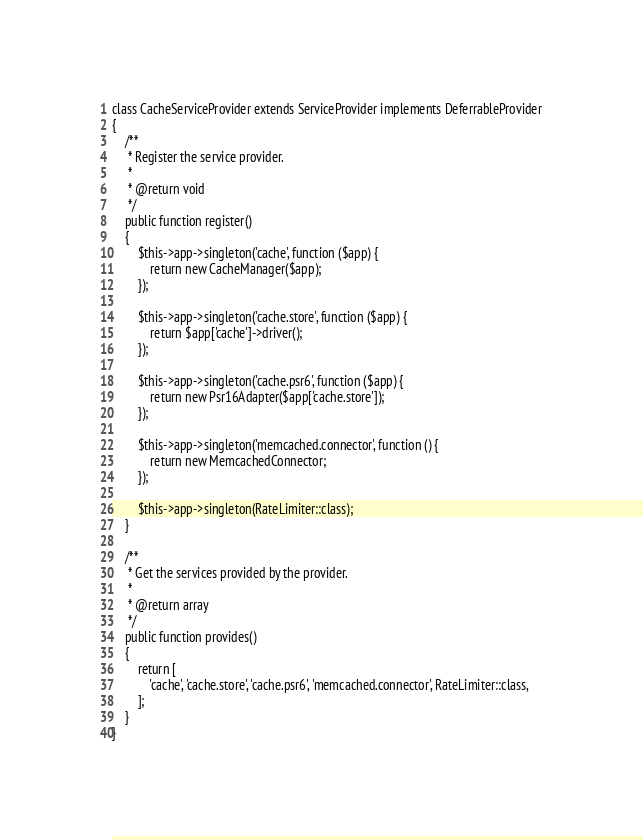Convert code to text. <code><loc_0><loc_0><loc_500><loc_500><_PHP_>
class CacheServiceProvider extends ServiceProvider implements DeferrableProvider
{
    /**
     * Register the service provider.
     *
     * @return void
     */
    public function register()
    {
        $this->app->singleton('cache', function ($app) {
            return new CacheManager($app);
        });

        $this->app->singleton('cache.store', function ($app) {
            return $app['cache']->driver();
        });

        $this->app->singleton('cache.psr6', function ($app) {
            return new Psr16Adapter($app['cache.store']);
        });

        $this->app->singleton('memcached.connector', function () {
            return new MemcachedConnector;
        });

        $this->app->singleton(RateLimiter::class);
    }

    /**
     * Get the services provided by the provider.
     *
     * @return array
     */
    public function provides()
    {
        return [
            'cache', 'cache.store', 'cache.psr6', 'memcached.connector', RateLimiter::class,
        ];
    }
}
</code> 